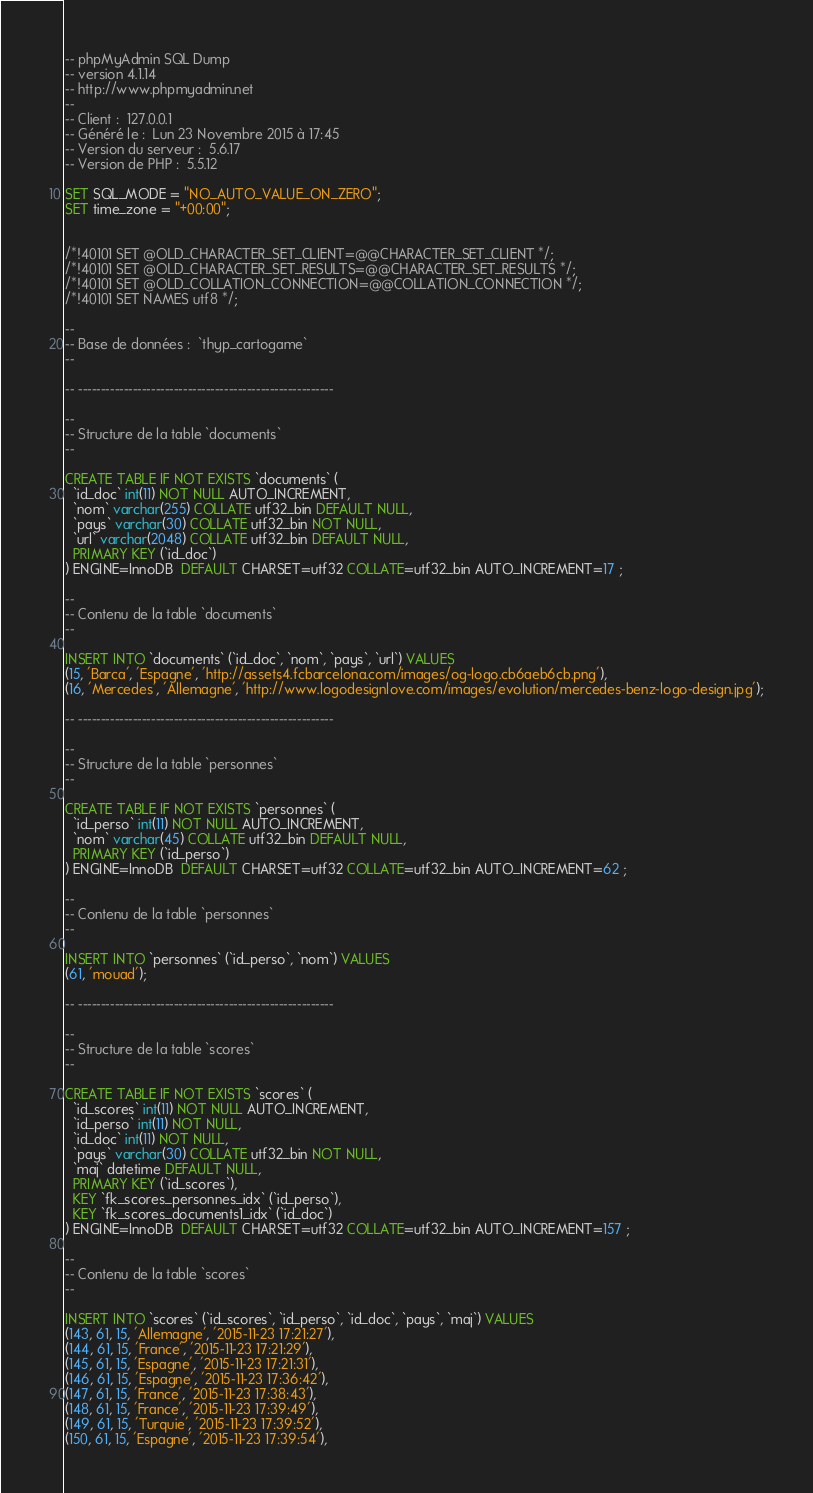<code> <loc_0><loc_0><loc_500><loc_500><_SQL_>-- phpMyAdmin SQL Dump
-- version 4.1.14
-- http://www.phpmyadmin.net
--
-- Client :  127.0.0.1
-- Généré le :  Lun 23 Novembre 2015 à 17:45
-- Version du serveur :  5.6.17
-- Version de PHP :  5.5.12

SET SQL_MODE = "NO_AUTO_VALUE_ON_ZERO";
SET time_zone = "+00:00";


/*!40101 SET @OLD_CHARACTER_SET_CLIENT=@@CHARACTER_SET_CLIENT */;
/*!40101 SET @OLD_CHARACTER_SET_RESULTS=@@CHARACTER_SET_RESULTS */;
/*!40101 SET @OLD_COLLATION_CONNECTION=@@COLLATION_CONNECTION */;
/*!40101 SET NAMES utf8 */;

--
-- Base de données :  `thyp_cartogame`
--

-- --------------------------------------------------------

--
-- Structure de la table `documents`
--

CREATE TABLE IF NOT EXISTS `documents` (
  `id_doc` int(11) NOT NULL AUTO_INCREMENT,
  `nom` varchar(255) COLLATE utf32_bin DEFAULT NULL,
  `pays` varchar(30) COLLATE utf32_bin NOT NULL,
  `url` varchar(2048) COLLATE utf32_bin DEFAULT NULL,
  PRIMARY KEY (`id_doc`)
) ENGINE=InnoDB  DEFAULT CHARSET=utf32 COLLATE=utf32_bin AUTO_INCREMENT=17 ;

--
-- Contenu de la table `documents`
--

INSERT INTO `documents` (`id_doc`, `nom`, `pays`, `url`) VALUES
(15, 'Barca', 'Espagne', 'http://assets4.fcbarcelona.com/images/og-logo.cb6aeb6cb.png'),
(16, 'Mercedes', 'Allemagne', 'http://www.logodesignlove.com/images/evolution/mercedes-benz-logo-design.jpg');

-- --------------------------------------------------------

--
-- Structure de la table `personnes`
--

CREATE TABLE IF NOT EXISTS `personnes` (
  `id_perso` int(11) NOT NULL AUTO_INCREMENT,
  `nom` varchar(45) COLLATE utf32_bin DEFAULT NULL,
  PRIMARY KEY (`id_perso`)
) ENGINE=InnoDB  DEFAULT CHARSET=utf32 COLLATE=utf32_bin AUTO_INCREMENT=62 ;

--
-- Contenu de la table `personnes`
--

INSERT INTO `personnes` (`id_perso`, `nom`) VALUES
(61, 'mouad');

-- --------------------------------------------------------

--
-- Structure de la table `scores`
--

CREATE TABLE IF NOT EXISTS `scores` (
  `id_scores` int(11) NOT NULL AUTO_INCREMENT,
  `id_perso` int(11) NOT NULL,
  `id_doc` int(11) NOT NULL,
  `pays` varchar(30) COLLATE utf32_bin NOT NULL,
  `maj` datetime DEFAULT NULL,
  PRIMARY KEY (`id_scores`),
  KEY `fk_scores_personnes_idx` (`id_perso`),
  KEY `fk_scores_documents1_idx` (`id_doc`)
) ENGINE=InnoDB  DEFAULT CHARSET=utf32 COLLATE=utf32_bin AUTO_INCREMENT=157 ;

--
-- Contenu de la table `scores`
--

INSERT INTO `scores` (`id_scores`, `id_perso`, `id_doc`, `pays`, `maj`) VALUES
(143, 61, 15, 'Allemagne', '2015-11-23 17:21:27'),
(144, 61, 15, 'France', '2015-11-23 17:21:29'),
(145, 61, 15, 'Espagne', '2015-11-23 17:21:31'),
(146, 61, 15, 'Espagne', '2015-11-23 17:36:42'),
(147, 61, 15, 'France', '2015-11-23 17:38:43'),
(148, 61, 15, 'France', '2015-11-23 17:39:49'),
(149, 61, 15, 'Turquie', '2015-11-23 17:39:52'),
(150, 61, 15, 'Espagne', '2015-11-23 17:39:54'),</code> 